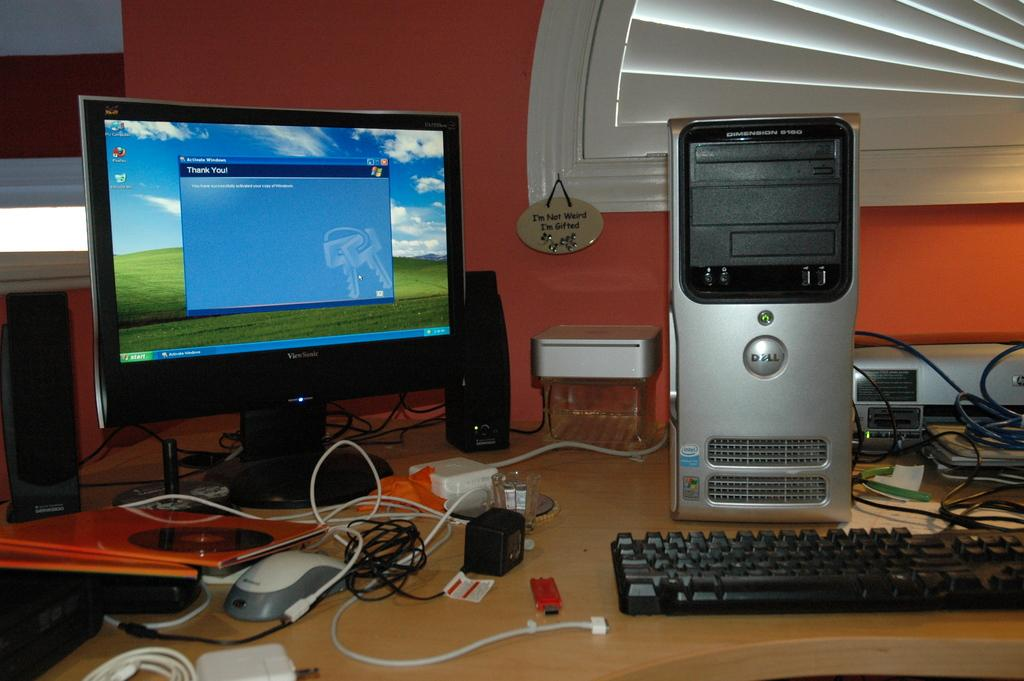<image>
Describe the image concisely. A Dell computer set up on a desk next to a monitor, keyboard, mouse, and some cords. 